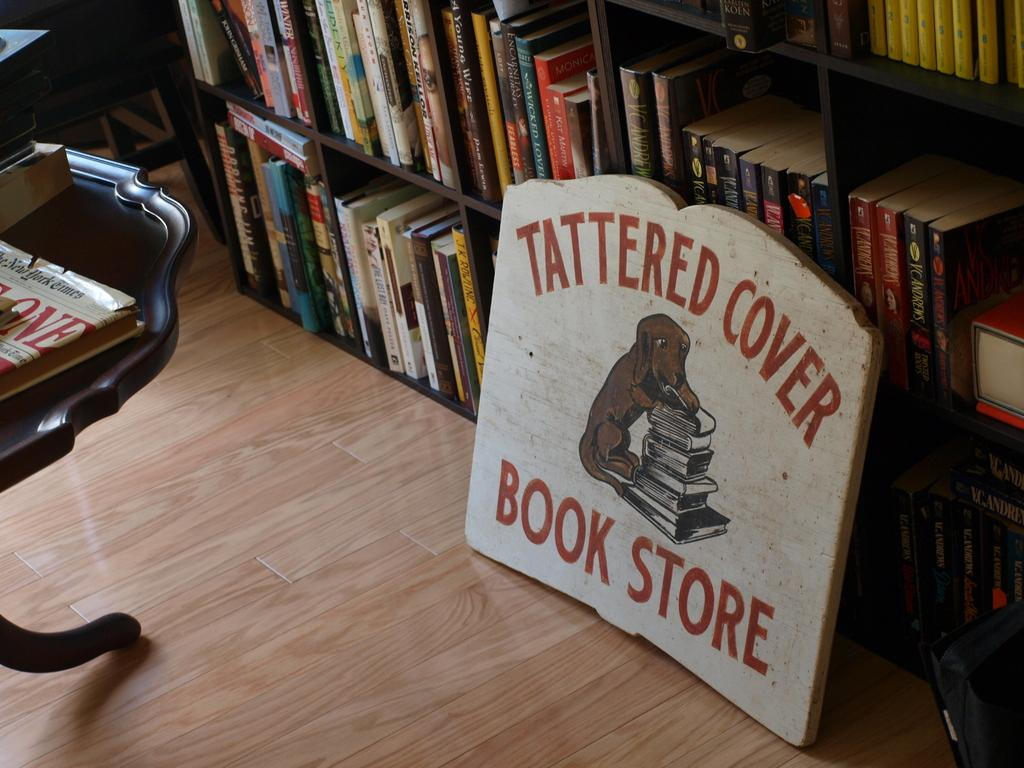Provide a one-sentence caption for the provided image. the words tattered cover book store on a brown surface. 